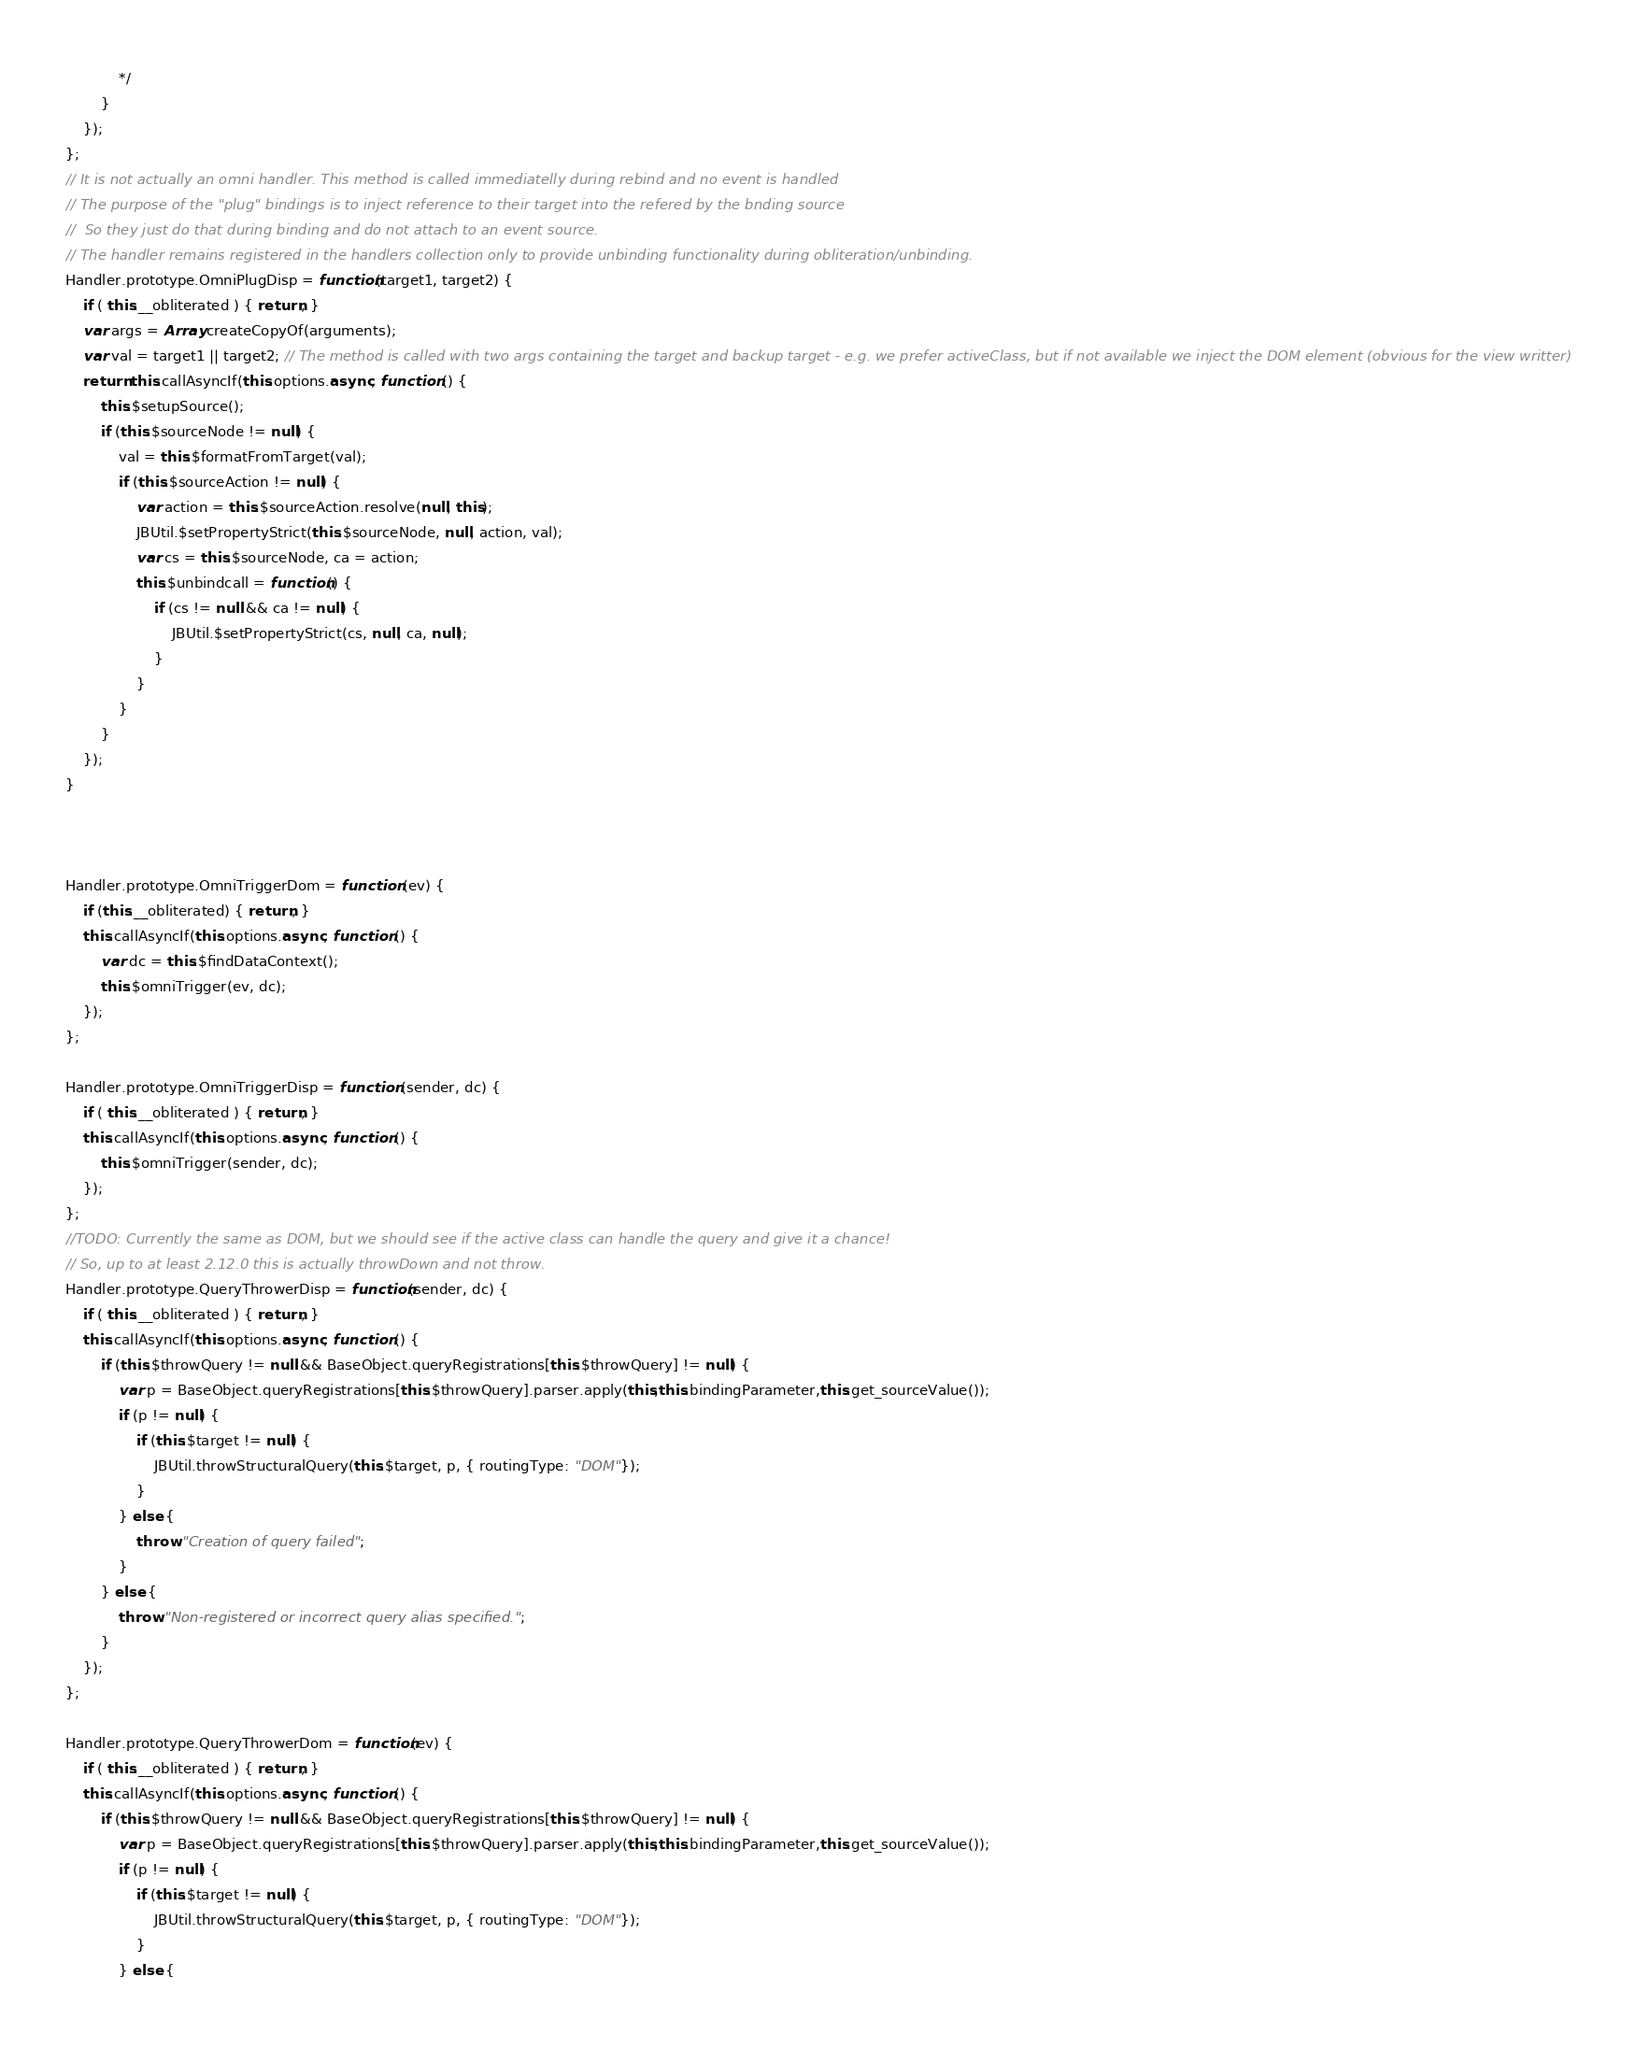Convert code to text. <code><loc_0><loc_0><loc_500><loc_500><_JavaScript_>			*/
		}
	});
};
// It is not actually an omni handler. This method is called immediatelly during rebind and no event is handled
// The purpose of the "plug" bindings is to inject reference to their target into the refered by the bnding source
//	So they just do that during binding and do not attach to an event source.
// The handler remains registered in the handlers collection only to provide unbinding functionality during obliteration/unbinding.
Handler.prototype.OmniPlugDisp = function(target1, target2) {
	if ( this.__obliterated ) { return; }
	var args = Array.createCopyOf(arguments);
	var val = target1 || target2; // The method is called with two args containing the target and backup target - e.g. we prefer activeClass, but if not available we inject the DOM element (obvious for the view writter)
	return this.callAsyncIf(this.options.async, function () {
		this.$setupSource();
		if (this.$sourceNode != null) {
			val = this.$formatFromTarget(val);
			if (this.$sourceAction != null) {
				var action = this.$sourceAction.resolve(null, this);
				JBUtil.$setPropertyStrict(this.$sourceNode, null, action, val);
				var cs = this.$sourceNode, ca = action;
				this.$unbindcall = function() {	
					if (cs != null && ca != null) {
						JBUtil.$setPropertyStrict(cs, null, ca, null);
					}
				}
			}
		}
	});
}



Handler.prototype.OmniTriggerDom = function (ev) {
	if (this.__obliterated) { return; }
    this.callAsyncIf(this.options.async, function () {
        var dc = this.$findDataContext();
        this.$omniTrigger(ev, dc);
    });    
};

Handler.prototype.OmniTriggerDisp = function (sender, dc) {
	if ( this.__obliterated ) { return; }
	this.callAsyncIf(this.options.async, function () {
        this.$omniTrigger(sender, dc);
    });    
};
//TODO: Currently the same as DOM, but we should see if the active class can handle the query and give it a chance!
// So, up to at least 2.12.0 this is actually throwDown and not throw.
Handler.prototype.QueryThrowerDisp = function(sender, dc) {
	if ( this.__obliterated ) { return; }
	this.callAsyncIf(this.options.async, function () {
		if (this.$throwQuery != null && BaseObject.queryRegistrations[this.$throwQuery] != null) {
			var p = BaseObject.queryRegistrations[this.$throwQuery].parser.apply(this,this.bindingParameter,this.get_sourceValue());
			if (p != null) {
				if (this.$target != null) {
					JBUtil.throwStructuralQuery(this.$target, p, { routingType: "DOM"});
				}
			} else {
				throw "Creation of query failed";
			}
		} else {
			throw "Non-registered or incorrect query alias specified.";
		}
	});
};

Handler.prototype.QueryThrowerDom = function(ev) {
	if ( this.__obliterated ) { return; }
	this.callAsyncIf(this.options.async, function () {
		if (this.$throwQuery != null && BaseObject.queryRegistrations[this.$throwQuery] != null) {
			var p = BaseObject.queryRegistrations[this.$throwQuery].parser.apply(this,this.bindingParameter,this.get_sourceValue());
			if (p != null) {
				if (this.$target != null) {
					JBUtil.throwStructuralQuery(this.$target, p, { routingType: "DOM"});
				}
			} else {</code> 